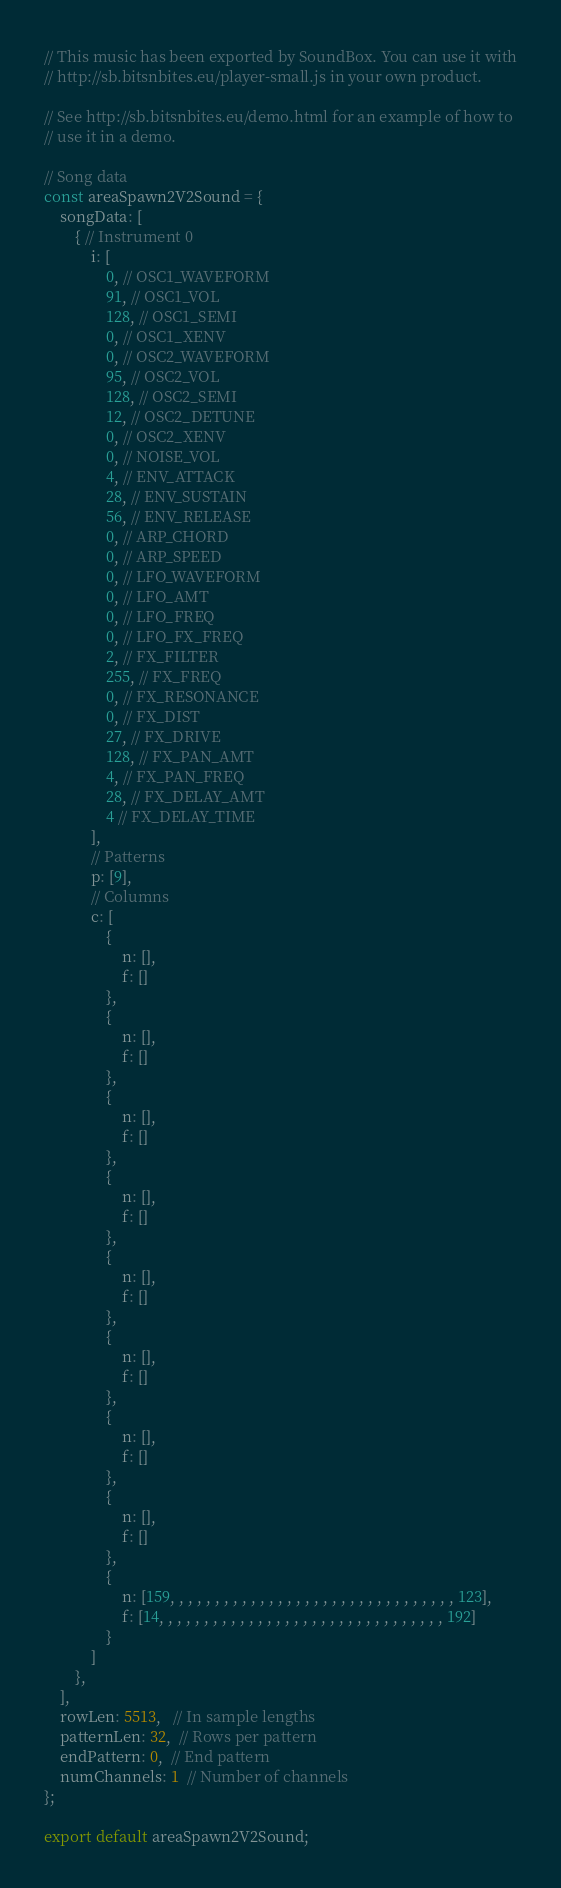Convert code to text. <code><loc_0><loc_0><loc_500><loc_500><_TypeScript_>// This music has been exported by SoundBox. You can use it with
// http://sb.bitsnbites.eu/player-small.js in your own product.

// See http://sb.bitsnbites.eu/demo.html for an example of how to
// use it in a demo.

// Song data
const areaSpawn2V2Sound = {
    songData: [
        { // Instrument 0
            i: [
                0, // OSC1_WAVEFORM
                91, // OSC1_VOL
                128, // OSC1_SEMI
                0, // OSC1_XENV
                0, // OSC2_WAVEFORM
                95, // OSC2_VOL
                128, // OSC2_SEMI
                12, // OSC2_DETUNE
                0, // OSC2_XENV
                0, // NOISE_VOL
                4, // ENV_ATTACK
                28, // ENV_SUSTAIN
                56, // ENV_RELEASE
                0, // ARP_CHORD
                0, // ARP_SPEED
                0, // LFO_WAVEFORM
                0, // LFO_AMT
                0, // LFO_FREQ
                0, // LFO_FX_FREQ
                2, // FX_FILTER
                255, // FX_FREQ
                0, // FX_RESONANCE
                0, // FX_DIST
                27, // FX_DRIVE
                128, // FX_PAN_AMT
                4, // FX_PAN_FREQ
                28, // FX_DELAY_AMT
                4 // FX_DELAY_TIME
            ],
            // Patterns
            p: [9],
            // Columns
            c: [
                {
                    n: [],
                    f: []
                },
                {
                    n: [],
                    f: []
                },
                {
                    n: [],
                    f: []
                },
                {
                    n: [],
                    f: []
                },
                {
                    n: [],
                    f: []
                },
                {
                    n: [],
                    f: []
                },
                {
                    n: [],
                    f: []
                },
                {
                    n: [],
                    f: []
                },
                {
                    n: [159, , , , , , , , , , , , , , , , , , , , , , , , , , , , , , , , 123],
                    f: [14, , , , , , , , , , , , , , , , , , , , , , , , , , , , , , , , 192]
                }
            ]
        },
    ],
    rowLen: 5513,   // In sample lengths
    patternLen: 32,  // Rows per pattern
    endPattern: 0,  // End pattern
    numChannels: 1  // Number of channels
};

export default areaSpawn2V2Sound;
</code> 